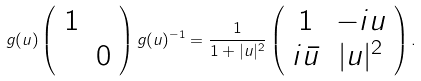<formula> <loc_0><loc_0><loc_500><loc_500>g ( u ) \left ( \begin{array} { c c } 1 & \\ & 0 \\ \end{array} \right ) g ( u ) ^ { - 1 } = \frac { 1 } { 1 + | u | ^ { 2 } } \left ( \begin{array} { c c } 1 & - i u \\ i \bar { u } & | u | ^ { 2 } \\ \end{array} \right ) .</formula> 